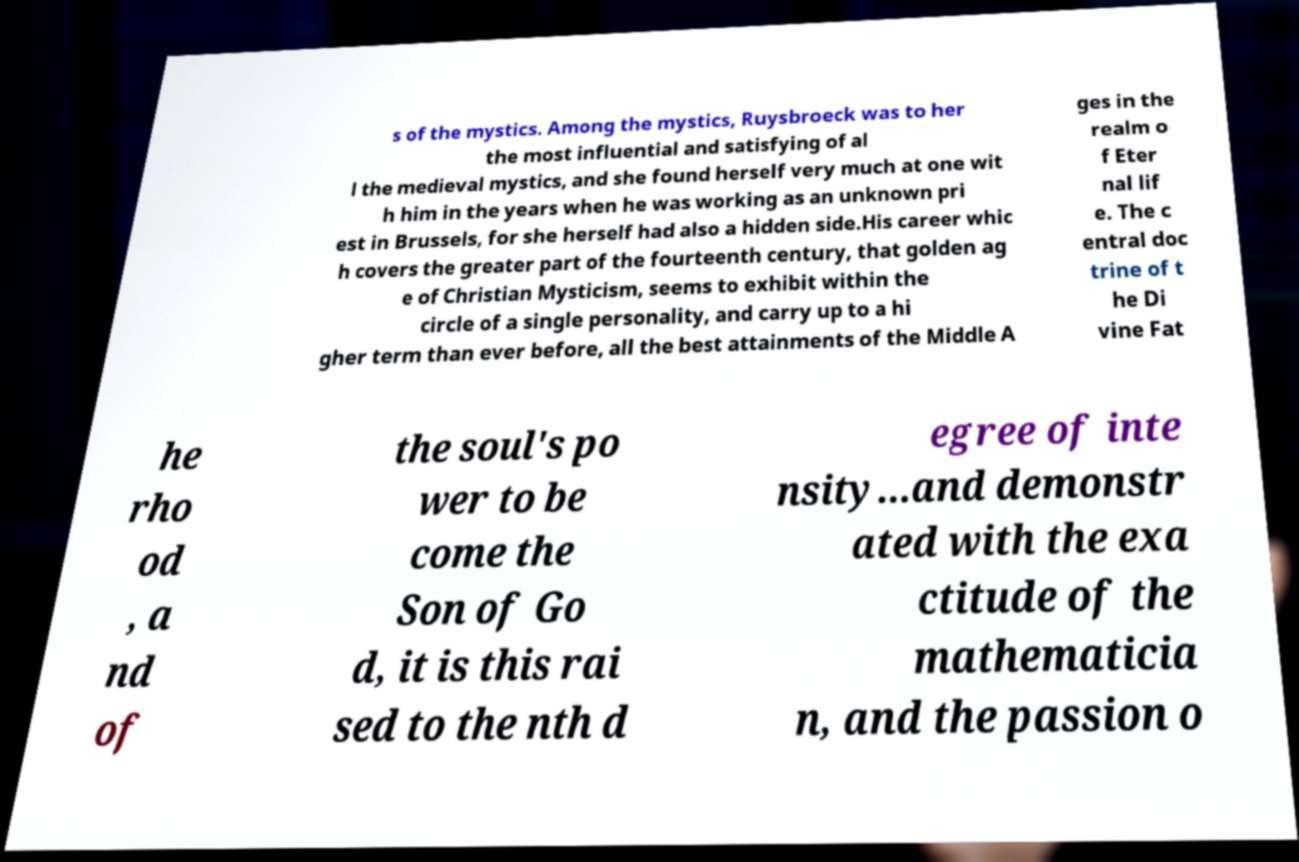Could you extract and type out the text from this image? s of the mystics. Among the mystics, Ruysbroeck was to her the most influential and satisfying of al l the medieval mystics, and she found herself very much at one wit h him in the years when he was working as an unknown pri est in Brussels, for she herself had also a hidden side.His career whic h covers the greater part of the fourteenth century, that golden ag e of Christian Mysticism, seems to exhibit within the circle of a single personality, and carry up to a hi gher term than ever before, all the best attainments of the Middle A ges in the realm o f Eter nal lif e. The c entral doc trine of t he Di vine Fat he rho od , a nd of the soul's po wer to be come the Son of Go d, it is this rai sed to the nth d egree of inte nsity...and demonstr ated with the exa ctitude of the mathematicia n, and the passion o 